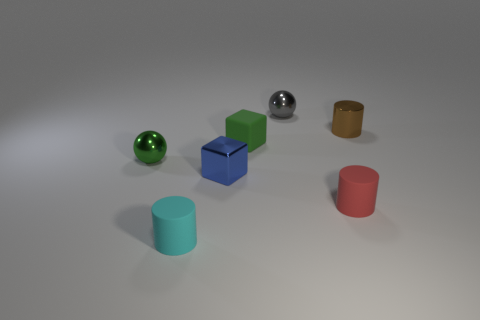There is a cylinder that is in front of the brown object and to the right of the tiny cyan rubber cylinder; what is its size?
Provide a short and direct response. Small. Are there any green metallic balls that are on the left side of the small ball that is right of the cylinder left of the gray object?
Keep it short and to the point. Yes. Are any small green matte cubes visible?
Make the answer very short. Yes. Are there more green matte things to the right of the small blue metallic cube than red things left of the tiny cyan rubber object?
Your answer should be compact. Yes. What color is the sphere that is to the right of the small green sphere?
Your response must be concise. Gray. Are there more small balls in front of the small metal cylinder than green matte cylinders?
Your answer should be compact. Yes. There is a small rubber thing that is on the right side of the tiny green block; does it have the same shape as the small brown metallic thing?
Your response must be concise. Yes. How many yellow objects are either rubber blocks or shiny balls?
Your response must be concise. 0. Is the number of tiny cyan metallic balls greater than the number of brown cylinders?
Provide a short and direct response. No. There is another cube that is the same size as the blue block; what color is it?
Your response must be concise. Green. 